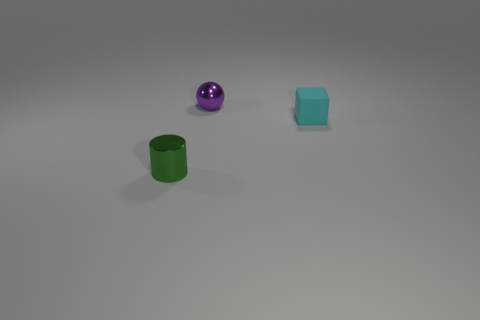What can you tell me about the lighting in this image? The lighting in the image appears to be diffused overhead lighting, casting soft shadows directly beneath the objects, suggesting an interior setting with a single light source above. 